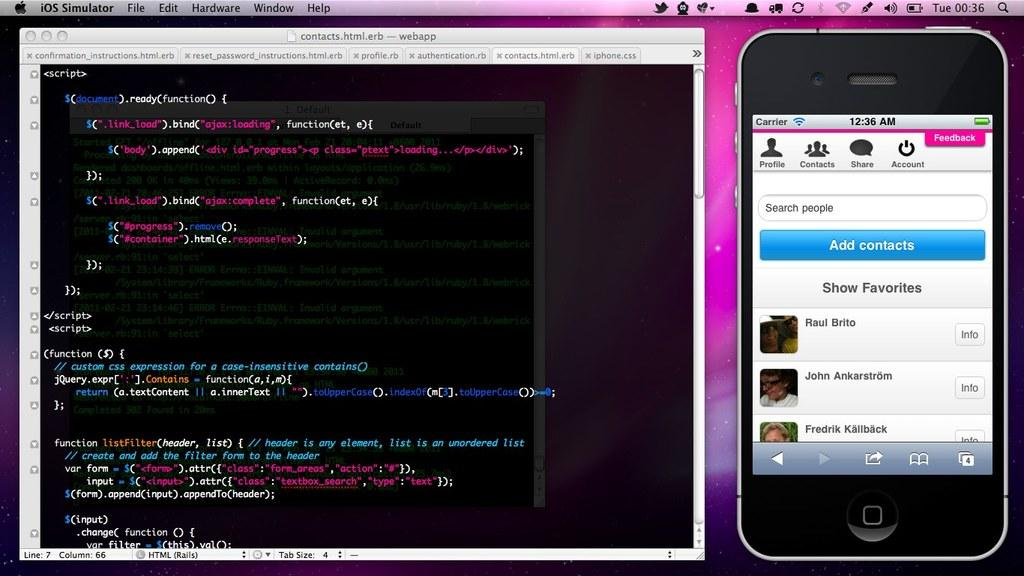Provide a one-sentence caption for the provided image. A computer screen shows a smart phone opened up to it's contacts and a web page to the left with page details written in code. 